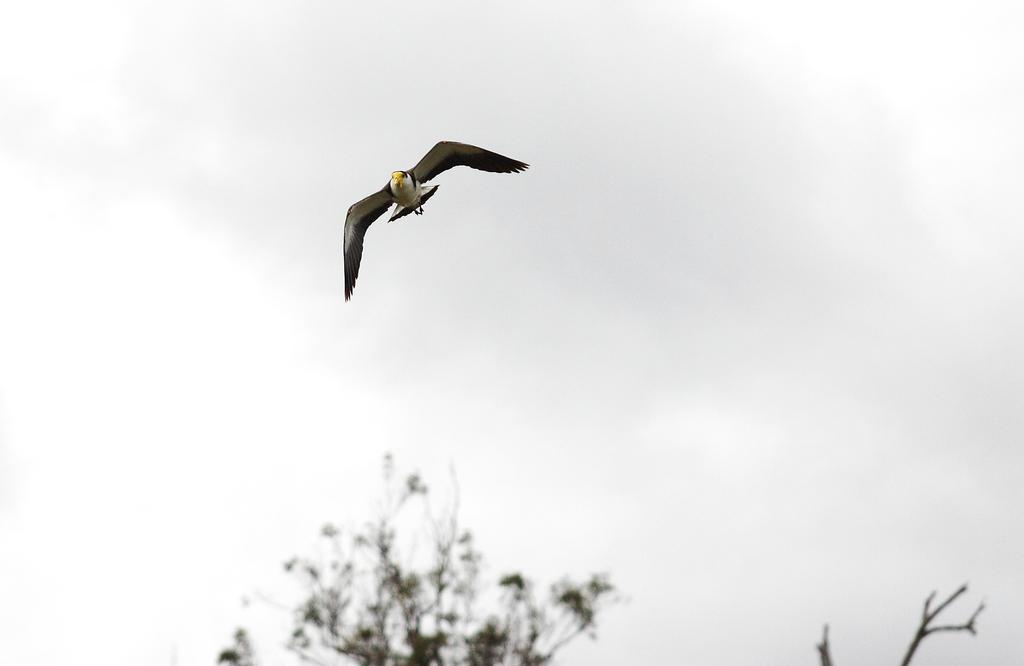Can you describe this image briefly? In the picture I can see a bird is flying in the air. The background of the image is blurred, where we can see trees and the cloudy sky. 